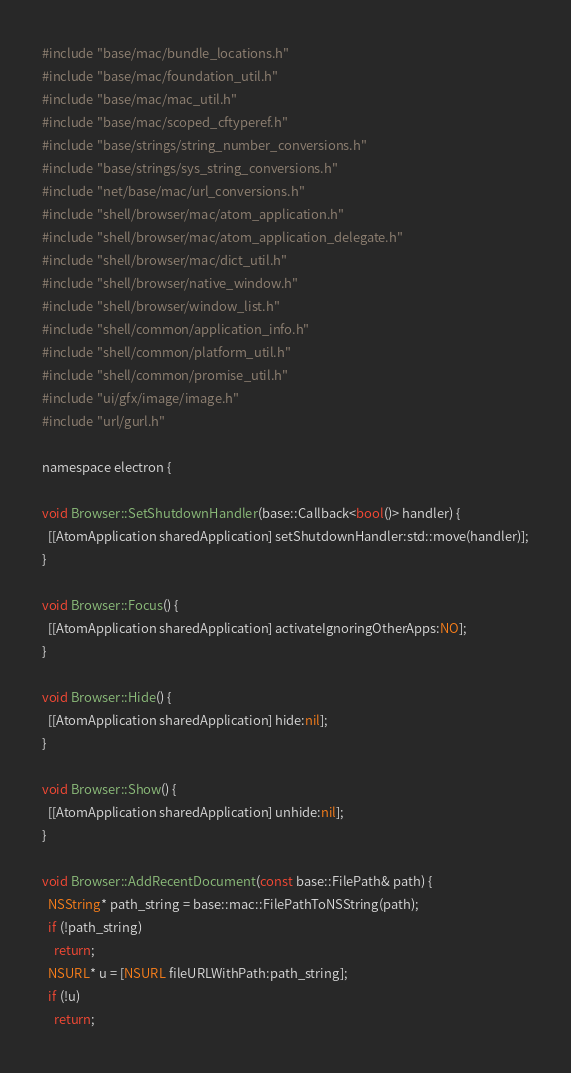<code> <loc_0><loc_0><loc_500><loc_500><_ObjectiveC_>#include "base/mac/bundle_locations.h"
#include "base/mac/foundation_util.h"
#include "base/mac/mac_util.h"
#include "base/mac/scoped_cftyperef.h"
#include "base/strings/string_number_conversions.h"
#include "base/strings/sys_string_conversions.h"
#include "net/base/mac/url_conversions.h"
#include "shell/browser/mac/atom_application.h"
#include "shell/browser/mac/atom_application_delegate.h"
#include "shell/browser/mac/dict_util.h"
#include "shell/browser/native_window.h"
#include "shell/browser/window_list.h"
#include "shell/common/application_info.h"
#include "shell/common/platform_util.h"
#include "shell/common/promise_util.h"
#include "ui/gfx/image/image.h"
#include "url/gurl.h"

namespace electron {

void Browser::SetShutdownHandler(base::Callback<bool()> handler) {
  [[AtomApplication sharedApplication] setShutdownHandler:std::move(handler)];
}

void Browser::Focus() {
  [[AtomApplication sharedApplication] activateIgnoringOtherApps:NO];
}

void Browser::Hide() {
  [[AtomApplication sharedApplication] hide:nil];
}

void Browser::Show() {
  [[AtomApplication sharedApplication] unhide:nil];
}

void Browser::AddRecentDocument(const base::FilePath& path) {
  NSString* path_string = base::mac::FilePathToNSString(path);
  if (!path_string)
    return;
  NSURL* u = [NSURL fileURLWithPath:path_string];
  if (!u)
    return;</code> 